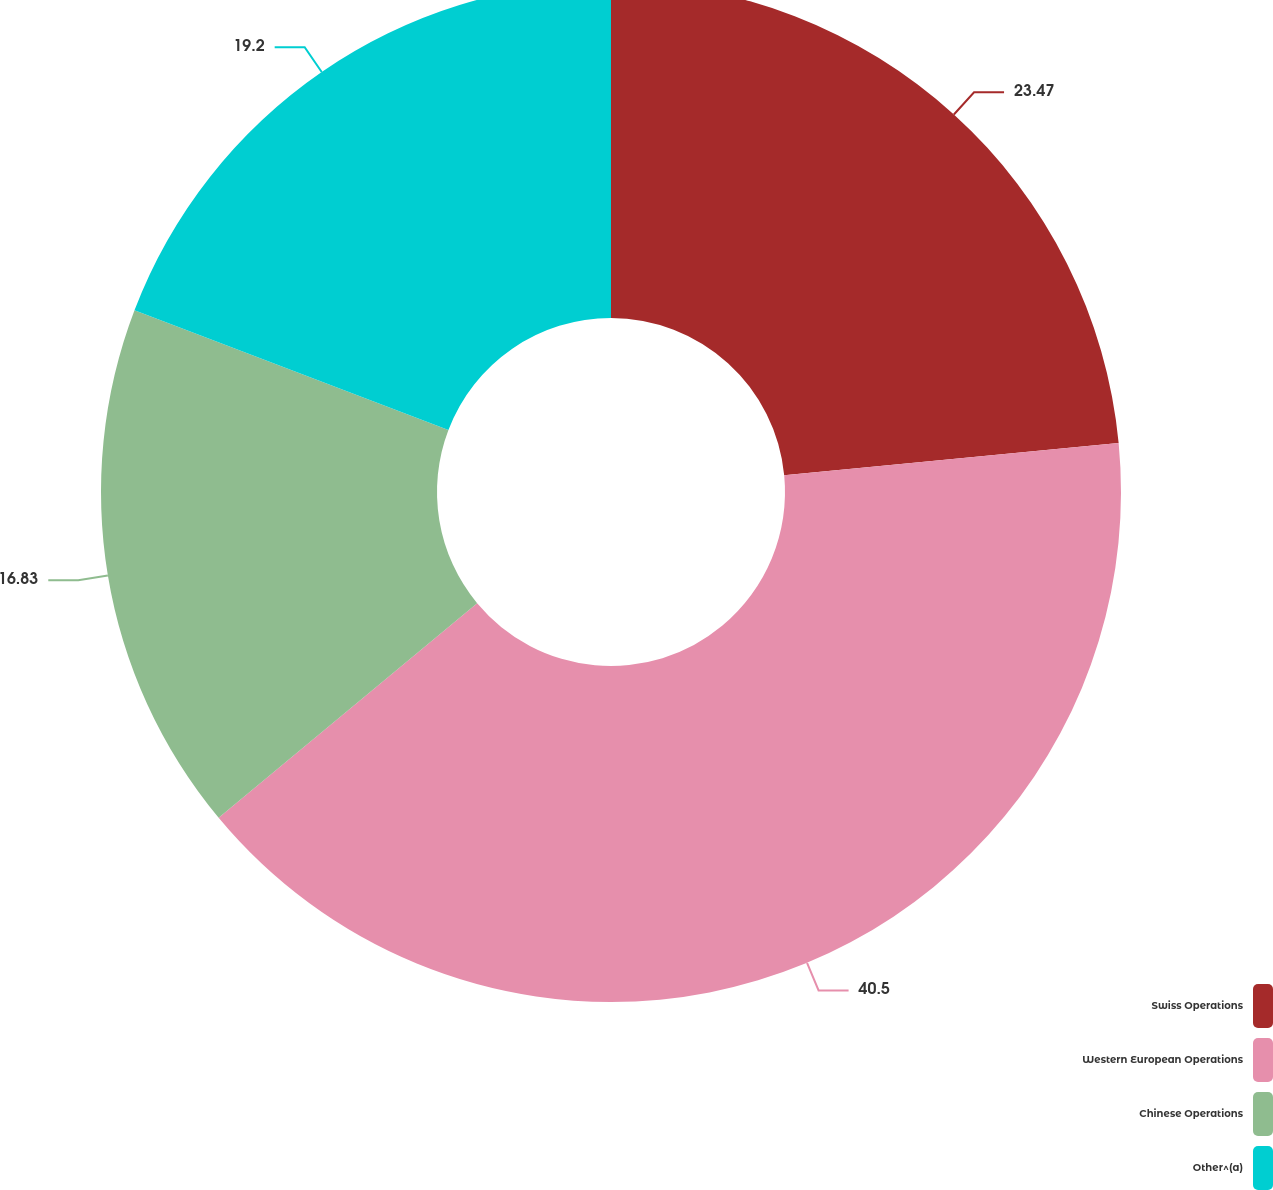Convert chart to OTSL. <chart><loc_0><loc_0><loc_500><loc_500><pie_chart><fcel>Swiss Operations<fcel>Western European Operations<fcel>Chinese Operations<fcel>Other^(a)<nl><fcel>23.47%<fcel>40.5%<fcel>16.83%<fcel>19.2%<nl></chart> 